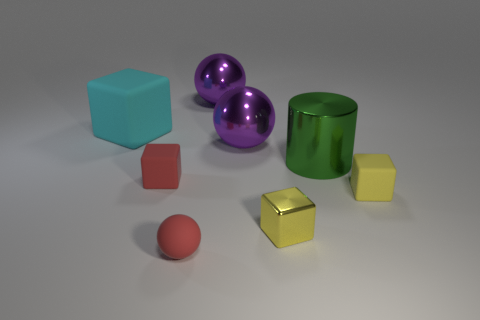The yellow object that is the same material as the big green object is what size?
Offer a very short reply. Small. What size is the green thing?
Offer a terse response. Large. The cyan object is what shape?
Give a very brief answer. Cube. There is a small rubber block that is in front of the small red rubber cube; is its color the same as the tiny shiny thing?
Make the answer very short. Yes. The metallic object that is the same shape as the cyan matte object is what size?
Make the answer very short. Small. Is there anything else that is made of the same material as the big green object?
Keep it short and to the point. Yes. There is a yellow object that is on the right side of the large metal cylinder that is behind the yellow metal cube; are there any large cyan matte cubes to the right of it?
Your response must be concise. No. What is the material of the ball that is behind the large block?
Offer a terse response. Metal. What number of tiny things are either red matte objects or green cylinders?
Provide a short and direct response. 2. There is a yellow cube that is left of the green shiny thing; is its size the same as the tiny yellow rubber object?
Give a very brief answer. Yes. 